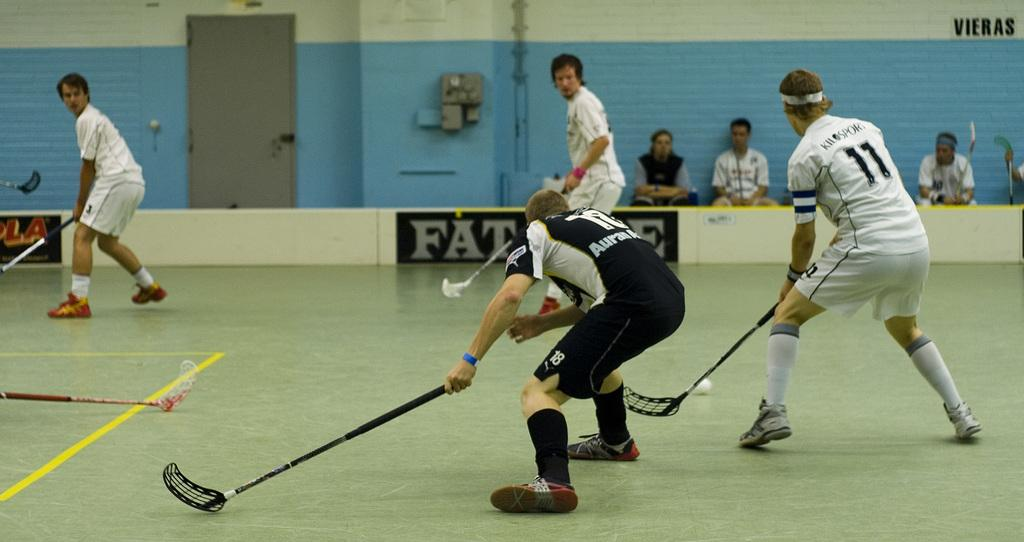What activity are the people in the image engaged in? The people in the image are playing a floor ball game. Are there any spectators in the image? Yes, there are other people sitting and watching the game in the image. What type of pot is being used to talk during the game in the image? There is no pot present in the image, and no one is talking through a pot during the game. 